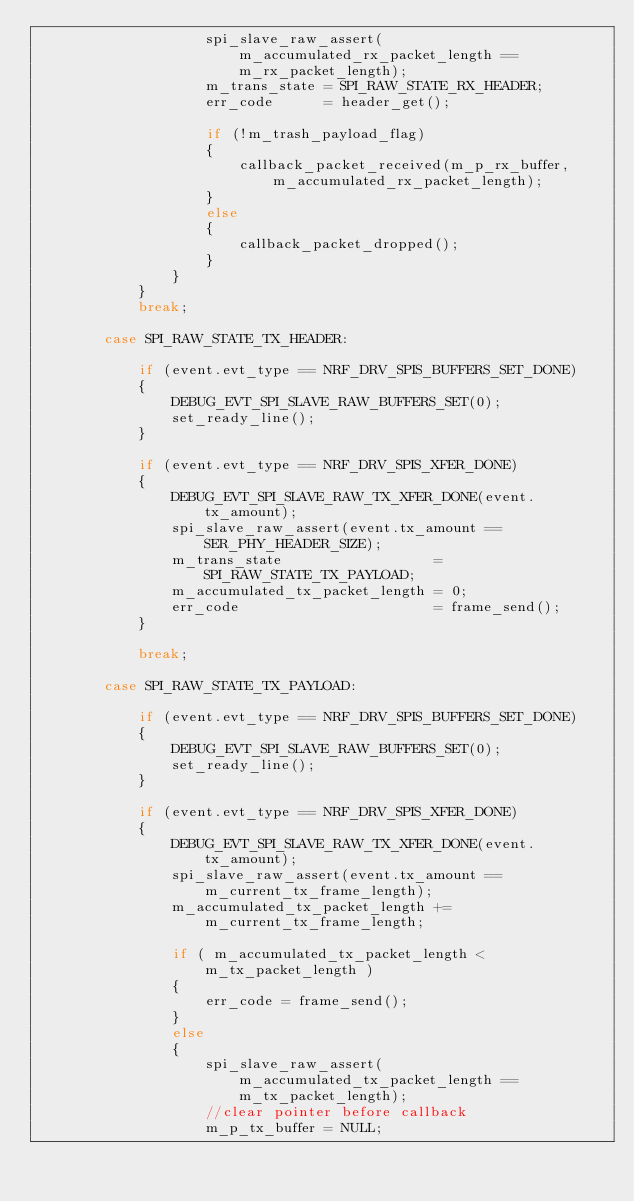<code> <loc_0><loc_0><loc_500><loc_500><_C_>                    spi_slave_raw_assert(m_accumulated_rx_packet_length == m_rx_packet_length);
                    m_trans_state = SPI_RAW_STATE_RX_HEADER;
                    err_code      = header_get();

                    if (!m_trash_payload_flag)
                    {
                        callback_packet_received(m_p_rx_buffer, m_accumulated_rx_packet_length);
                    }
                    else
                    {
                        callback_packet_dropped();
                    }
                }
            }
            break;

        case SPI_RAW_STATE_TX_HEADER:

            if (event.evt_type == NRF_DRV_SPIS_BUFFERS_SET_DONE)
            {
                DEBUG_EVT_SPI_SLAVE_RAW_BUFFERS_SET(0);
                set_ready_line();
            }

            if (event.evt_type == NRF_DRV_SPIS_XFER_DONE)
            {
                DEBUG_EVT_SPI_SLAVE_RAW_TX_XFER_DONE(event.tx_amount);
                spi_slave_raw_assert(event.tx_amount == SER_PHY_HEADER_SIZE);
                m_trans_state                  = SPI_RAW_STATE_TX_PAYLOAD;
                m_accumulated_tx_packet_length = 0;
                err_code                       = frame_send();
            }

            break;

        case SPI_RAW_STATE_TX_PAYLOAD:

            if (event.evt_type == NRF_DRV_SPIS_BUFFERS_SET_DONE)
            {
                DEBUG_EVT_SPI_SLAVE_RAW_BUFFERS_SET(0);
                set_ready_line();
            }

            if (event.evt_type == NRF_DRV_SPIS_XFER_DONE)
            {
                DEBUG_EVT_SPI_SLAVE_RAW_TX_XFER_DONE(event.tx_amount);
                spi_slave_raw_assert(event.tx_amount == m_current_tx_frame_length);
                m_accumulated_tx_packet_length += m_current_tx_frame_length;

                if ( m_accumulated_tx_packet_length < m_tx_packet_length )
                {
                    err_code = frame_send();
                }
                else
                {
                    spi_slave_raw_assert(m_accumulated_tx_packet_length == m_tx_packet_length);
                    //clear pointer before callback
                    m_p_tx_buffer = NULL;</code> 